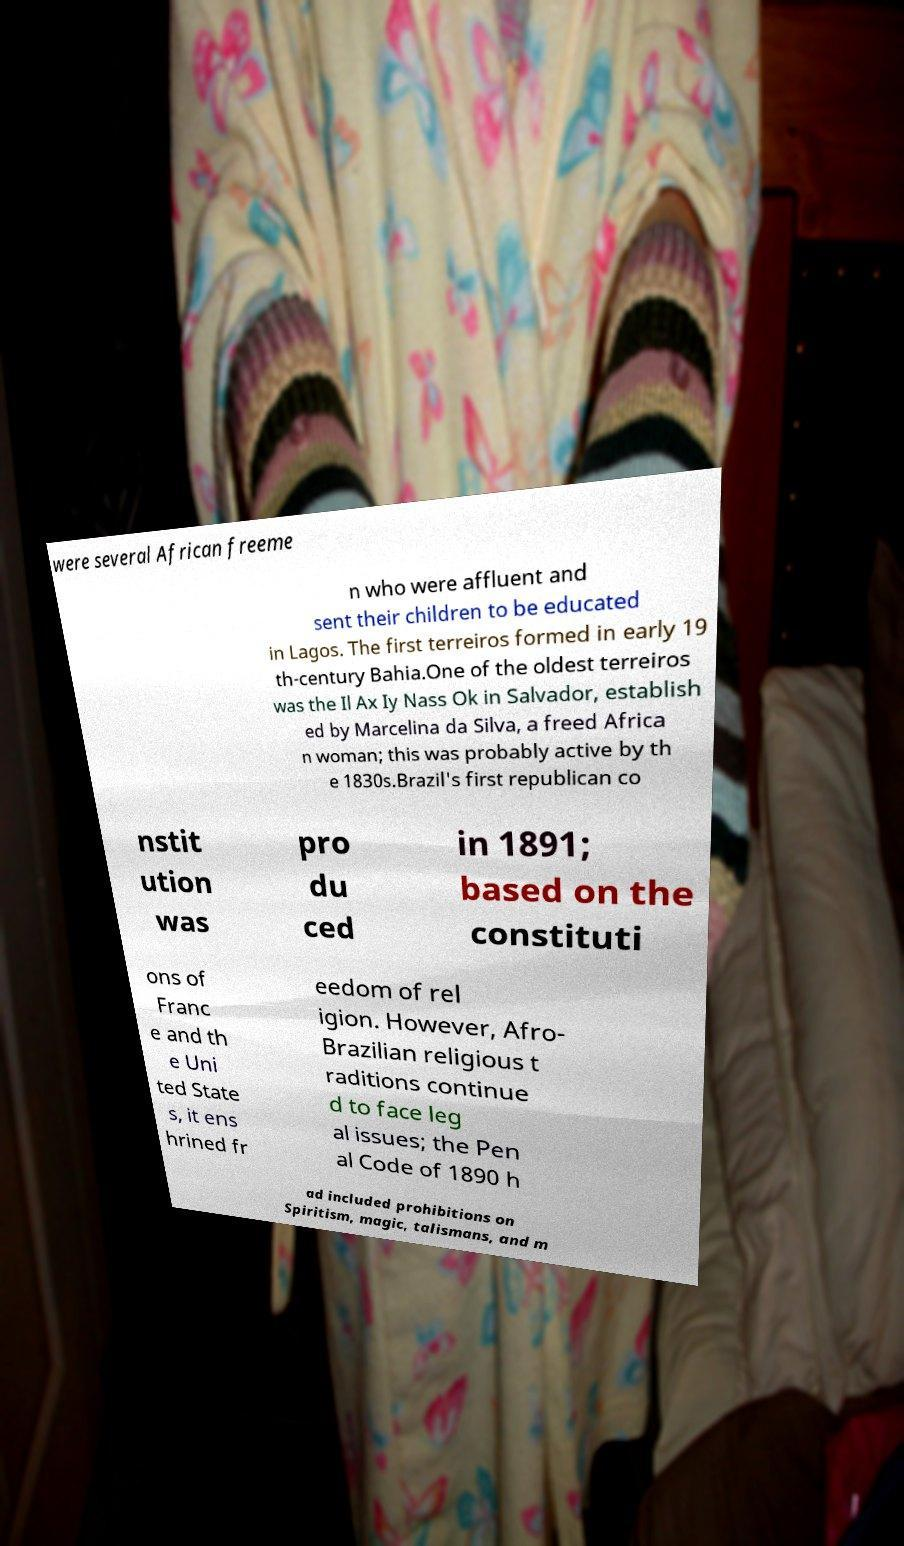What messages or text are displayed in this image? I need them in a readable, typed format. were several African freeme n who were affluent and sent their children to be educated in Lagos. The first terreiros formed in early 19 th-century Bahia.One of the oldest terreiros was the Il Ax Iy Nass Ok in Salvador, establish ed by Marcelina da Silva, a freed Africa n woman; this was probably active by th e 1830s.Brazil's first republican co nstit ution was pro du ced in 1891; based on the constituti ons of Franc e and th e Uni ted State s, it ens hrined fr eedom of rel igion. However, Afro- Brazilian religious t raditions continue d to face leg al issues; the Pen al Code of 1890 h ad included prohibitions on Spiritism, magic, talismans, and m 